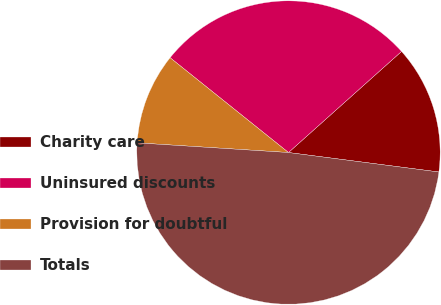<chart> <loc_0><loc_0><loc_500><loc_500><pie_chart><fcel>Charity care<fcel>Uninsured discounts<fcel>Provision for doubtful<fcel>Totals<nl><fcel>13.66%<fcel>27.64%<fcel>9.73%<fcel>48.97%<nl></chart> 